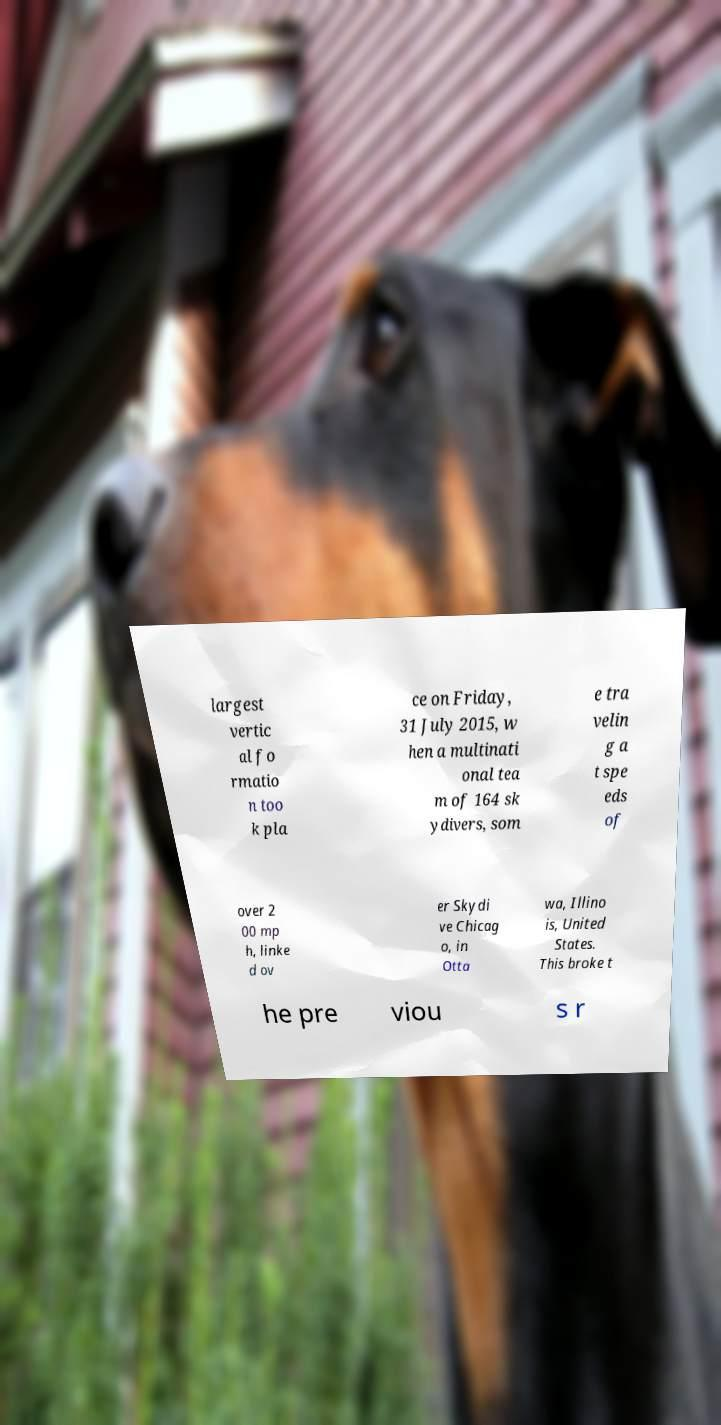Could you extract and type out the text from this image? largest vertic al fo rmatio n too k pla ce on Friday, 31 July 2015, w hen a multinati onal tea m of 164 sk ydivers, som e tra velin g a t spe eds of over 2 00 mp h, linke d ov er Skydi ve Chicag o, in Otta wa, Illino is, United States. This broke t he pre viou s r 